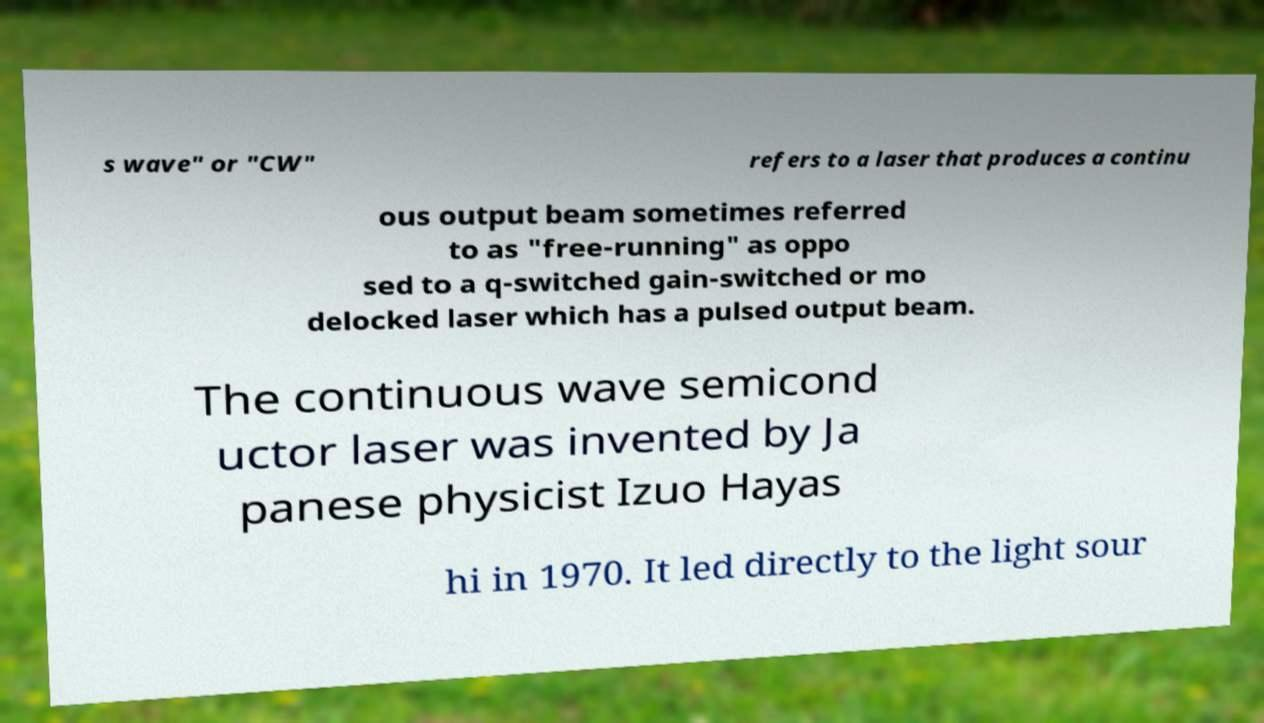What messages or text are displayed in this image? I need them in a readable, typed format. s wave" or "CW" refers to a laser that produces a continu ous output beam sometimes referred to as "free-running" as oppo sed to a q-switched gain-switched or mo delocked laser which has a pulsed output beam. The continuous wave semicond uctor laser was invented by Ja panese physicist Izuo Hayas hi in 1970. It led directly to the light sour 